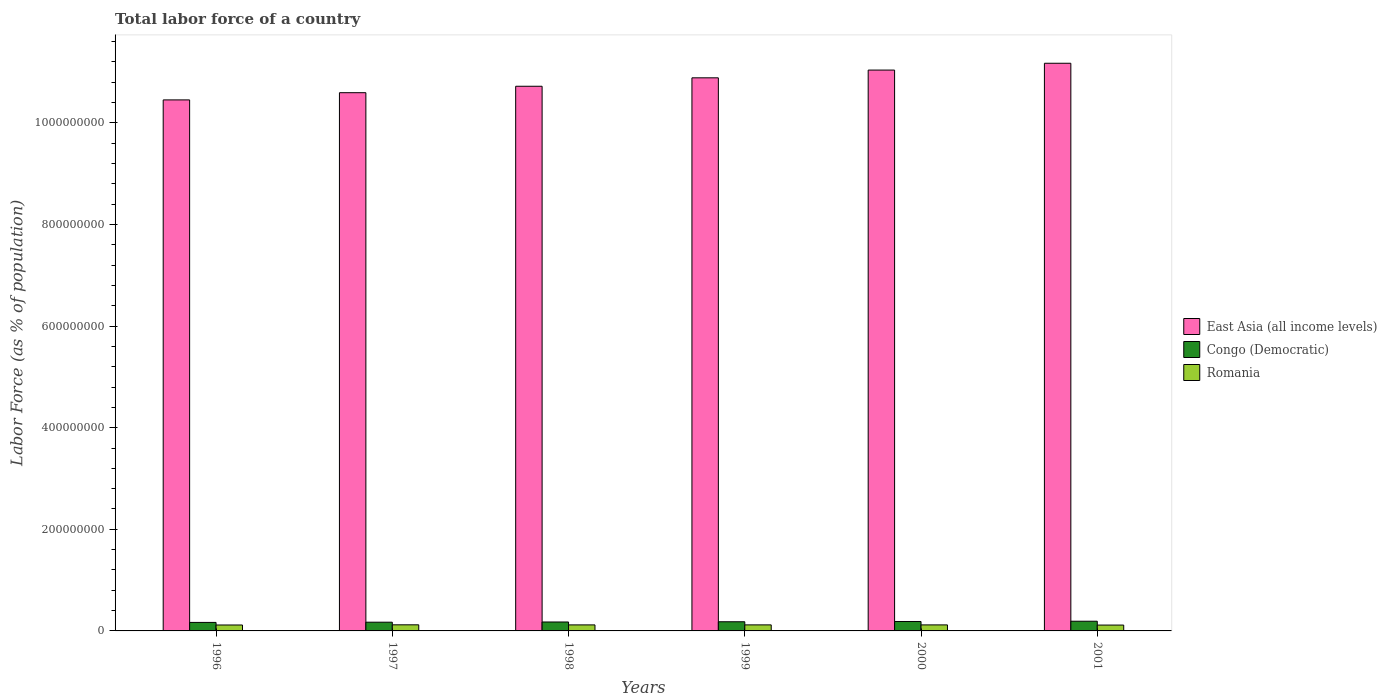How many different coloured bars are there?
Offer a terse response. 3. Are the number of bars on each tick of the X-axis equal?
Your answer should be compact. Yes. How many bars are there on the 5th tick from the left?
Make the answer very short. 3. How many bars are there on the 4th tick from the right?
Your answer should be compact. 3. What is the label of the 1st group of bars from the left?
Your answer should be compact. 1996. What is the percentage of labor force in Romania in 2000?
Keep it short and to the point. 1.19e+07. Across all years, what is the maximum percentage of labor force in Congo (Democratic)?
Provide a succinct answer. 1.91e+07. Across all years, what is the minimum percentage of labor force in Congo (Democratic)?
Keep it short and to the point. 1.67e+07. What is the total percentage of labor force in Romania in the graph?
Your response must be concise. 7.08e+07. What is the difference between the percentage of labor force in Congo (Democratic) in 1996 and that in 2001?
Keep it short and to the point. -2.33e+06. What is the difference between the percentage of labor force in Romania in 1998 and the percentage of labor force in East Asia (all income levels) in 1997?
Offer a very short reply. -1.05e+09. What is the average percentage of labor force in Congo (Democratic) per year?
Keep it short and to the point. 1.79e+07. In the year 2000, what is the difference between the percentage of labor force in East Asia (all income levels) and percentage of labor force in Congo (Democratic)?
Provide a short and direct response. 1.09e+09. What is the ratio of the percentage of labor force in Congo (Democratic) in 1998 to that in 1999?
Give a very brief answer. 0.98. Is the percentage of labor force in East Asia (all income levels) in 1996 less than that in 1999?
Give a very brief answer. Yes. What is the difference between the highest and the second highest percentage of labor force in East Asia (all income levels)?
Keep it short and to the point. 1.34e+07. What is the difference between the highest and the lowest percentage of labor force in Congo (Democratic)?
Your response must be concise. 2.33e+06. In how many years, is the percentage of labor force in East Asia (all income levels) greater than the average percentage of labor force in East Asia (all income levels) taken over all years?
Offer a very short reply. 3. Is the sum of the percentage of labor force in Congo (Democratic) in 1996 and 2001 greater than the maximum percentage of labor force in Romania across all years?
Keep it short and to the point. Yes. What does the 3rd bar from the left in 1999 represents?
Keep it short and to the point. Romania. What does the 2nd bar from the right in 2001 represents?
Your response must be concise. Congo (Democratic). How many bars are there?
Your response must be concise. 18. Are all the bars in the graph horizontal?
Offer a terse response. No. What is the difference between two consecutive major ticks on the Y-axis?
Provide a succinct answer. 2.00e+08. How many legend labels are there?
Provide a short and direct response. 3. How are the legend labels stacked?
Give a very brief answer. Vertical. What is the title of the graph?
Give a very brief answer. Total labor force of a country. Does "Italy" appear as one of the legend labels in the graph?
Provide a succinct answer. No. What is the label or title of the Y-axis?
Ensure brevity in your answer.  Labor Force (as % of population). What is the Labor Force (as % of population) of East Asia (all income levels) in 1996?
Offer a terse response. 1.05e+09. What is the Labor Force (as % of population) in Congo (Democratic) in 1996?
Your response must be concise. 1.67e+07. What is the Labor Force (as % of population) in Romania in 1996?
Offer a very short reply. 1.17e+07. What is the Labor Force (as % of population) in East Asia (all income levels) in 1997?
Offer a very short reply. 1.06e+09. What is the Labor Force (as % of population) in Congo (Democratic) in 1997?
Keep it short and to the point. 1.72e+07. What is the Labor Force (as % of population) of Romania in 1997?
Your answer should be compact. 1.20e+07. What is the Labor Force (as % of population) in East Asia (all income levels) in 1998?
Keep it short and to the point. 1.07e+09. What is the Labor Force (as % of population) of Congo (Democratic) in 1998?
Your response must be concise. 1.76e+07. What is the Labor Force (as % of population) in Romania in 1998?
Your answer should be compact. 1.19e+07. What is the Labor Force (as % of population) in East Asia (all income levels) in 1999?
Give a very brief answer. 1.09e+09. What is the Labor Force (as % of population) of Congo (Democratic) in 1999?
Make the answer very short. 1.80e+07. What is the Labor Force (as % of population) in Romania in 1999?
Your answer should be very brief. 1.19e+07. What is the Labor Force (as % of population) in East Asia (all income levels) in 2000?
Your response must be concise. 1.10e+09. What is the Labor Force (as % of population) of Congo (Democratic) in 2000?
Offer a very short reply. 1.86e+07. What is the Labor Force (as % of population) of Romania in 2000?
Make the answer very short. 1.19e+07. What is the Labor Force (as % of population) of East Asia (all income levels) in 2001?
Your answer should be compact. 1.12e+09. What is the Labor Force (as % of population) of Congo (Democratic) in 2001?
Give a very brief answer. 1.91e+07. What is the Labor Force (as % of population) in Romania in 2001?
Provide a short and direct response. 1.15e+07. Across all years, what is the maximum Labor Force (as % of population) in East Asia (all income levels)?
Offer a very short reply. 1.12e+09. Across all years, what is the maximum Labor Force (as % of population) in Congo (Democratic)?
Provide a short and direct response. 1.91e+07. Across all years, what is the maximum Labor Force (as % of population) of Romania?
Offer a terse response. 1.20e+07. Across all years, what is the minimum Labor Force (as % of population) in East Asia (all income levels)?
Provide a short and direct response. 1.05e+09. Across all years, what is the minimum Labor Force (as % of population) of Congo (Democratic)?
Keep it short and to the point. 1.67e+07. Across all years, what is the minimum Labor Force (as % of population) of Romania?
Ensure brevity in your answer.  1.15e+07. What is the total Labor Force (as % of population) of East Asia (all income levels) in the graph?
Make the answer very short. 6.49e+09. What is the total Labor Force (as % of population) in Congo (Democratic) in the graph?
Your answer should be compact. 1.07e+08. What is the total Labor Force (as % of population) in Romania in the graph?
Give a very brief answer. 7.08e+07. What is the difference between the Labor Force (as % of population) in East Asia (all income levels) in 1996 and that in 1997?
Your response must be concise. -1.42e+07. What is the difference between the Labor Force (as % of population) in Congo (Democratic) in 1996 and that in 1997?
Make the answer very short. -4.31e+05. What is the difference between the Labor Force (as % of population) of Romania in 1996 and that in 1997?
Your response must be concise. -3.55e+05. What is the difference between the Labor Force (as % of population) of East Asia (all income levels) in 1996 and that in 1998?
Keep it short and to the point. -2.69e+07. What is the difference between the Labor Force (as % of population) in Congo (Democratic) in 1996 and that in 1998?
Ensure brevity in your answer.  -8.44e+05. What is the difference between the Labor Force (as % of population) in Romania in 1996 and that in 1998?
Provide a succinct answer. -2.06e+05. What is the difference between the Labor Force (as % of population) of East Asia (all income levels) in 1996 and that in 1999?
Give a very brief answer. -4.35e+07. What is the difference between the Labor Force (as % of population) of Congo (Democratic) in 1996 and that in 1999?
Provide a succinct answer. -1.29e+06. What is the difference between the Labor Force (as % of population) in Romania in 1996 and that in 1999?
Ensure brevity in your answer.  -2.37e+05. What is the difference between the Labor Force (as % of population) in East Asia (all income levels) in 1996 and that in 2000?
Give a very brief answer. -5.87e+07. What is the difference between the Labor Force (as % of population) in Congo (Democratic) in 1996 and that in 2000?
Offer a very short reply. -1.81e+06. What is the difference between the Labor Force (as % of population) of Romania in 1996 and that in 2000?
Your response must be concise. -2.05e+05. What is the difference between the Labor Force (as % of population) in East Asia (all income levels) in 1996 and that in 2001?
Your response must be concise. -7.21e+07. What is the difference between the Labor Force (as % of population) of Congo (Democratic) in 1996 and that in 2001?
Keep it short and to the point. -2.33e+06. What is the difference between the Labor Force (as % of population) in Romania in 1996 and that in 2001?
Your answer should be compact. 1.58e+05. What is the difference between the Labor Force (as % of population) in East Asia (all income levels) in 1997 and that in 1998?
Offer a terse response. -1.27e+07. What is the difference between the Labor Force (as % of population) in Congo (Democratic) in 1997 and that in 1998?
Provide a succinct answer. -4.13e+05. What is the difference between the Labor Force (as % of population) of Romania in 1997 and that in 1998?
Your answer should be compact. 1.49e+05. What is the difference between the Labor Force (as % of population) in East Asia (all income levels) in 1997 and that in 1999?
Offer a terse response. -2.93e+07. What is the difference between the Labor Force (as % of population) in Congo (Democratic) in 1997 and that in 1999?
Your response must be concise. -8.60e+05. What is the difference between the Labor Force (as % of population) in Romania in 1997 and that in 1999?
Make the answer very short. 1.18e+05. What is the difference between the Labor Force (as % of population) of East Asia (all income levels) in 1997 and that in 2000?
Make the answer very short. -4.45e+07. What is the difference between the Labor Force (as % of population) of Congo (Democratic) in 1997 and that in 2000?
Your answer should be very brief. -1.38e+06. What is the difference between the Labor Force (as % of population) of Romania in 1997 and that in 2000?
Provide a succinct answer. 1.50e+05. What is the difference between the Labor Force (as % of population) in East Asia (all income levels) in 1997 and that in 2001?
Give a very brief answer. -5.79e+07. What is the difference between the Labor Force (as % of population) of Congo (Democratic) in 1997 and that in 2001?
Give a very brief answer. -1.89e+06. What is the difference between the Labor Force (as % of population) in Romania in 1997 and that in 2001?
Offer a very short reply. 5.13e+05. What is the difference between the Labor Force (as % of population) of East Asia (all income levels) in 1998 and that in 1999?
Provide a short and direct response. -1.66e+07. What is the difference between the Labor Force (as % of population) of Congo (Democratic) in 1998 and that in 1999?
Keep it short and to the point. -4.47e+05. What is the difference between the Labor Force (as % of population) in Romania in 1998 and that in 1999?
Offer a very short reply. -3.07e+04. What is the difference between the Labor Force (as % of population) in East Asia (all income levels) in 1998 and that in 2000?
Provide a succinct answer. -3.19e+07. What is the difference between the Labor Force (as % of population) of Congo (Democratic) in 1998 and that in 2000?
Offer a very short reply. -9.70e+05. What is the difference between the Labor Force (as % of population) in Romania in 1998 and that in 2000?
Your answer should be compact. 1094. What is the difference between the Labor Force (as % of population) of East Asia (all income levels) in 1998 and that in 2001?
Offer a very short reply. -4.53e+07. What is the difference between the Labor Force (as % of population) in Congo (Democratic) in 1998 and that in 2001?
Ensure brevity in your answer.  -1.48e+06. What is the difference between the Labor Force (as % of population) in Romania in 1998 and that in 2001?
Keep it short and to the point. 3.64e+05. What is the difference between the Labor Force (as % of population) of East Asia (all income levels) in 1999 and that in 2000?
Provide a short and direct response. -1.53e+07. What is the difference between the Labor Force (as % of population) in Congo (Democratic) in 1999 and that in 2000?
Your answer should be very brief. -5.23e+05. What is the difference between the Labor Force (as % of population) of Romania in 1999 and that in 2000?
Give a very brief answer. 3.18e+04. What is the difference between the Labor Force (as % of population) of East Asia (all income levels) in 1999 and that in 2001?
Offer a terse response. -2.87e+07. What is the difference between the Labor Force (as % of population) of Congo (Democratic) in 1999 and that in 2001?
Provide a short and direct response. -1.03e+06. What is the difference between the Labor Force (as % of population) of Romania in 1999 and that in 2001?
Offer a very short reply. 3.95e+05. What is the difference between the Labor Force (as % of population) in East Asia (all income levels) in 2000 and that in 2001?
Your answer should be compact. -1.34e+07. What is the difference between the Labor Force (as % of population) in Congo (Democratic) in 2000 and that in 2001?
Provide a succinct answer. -5.12e+05. What is the difference between the Labor Force (as % of population) in Romania in 2000 and that in 2001?
Provide a short and direct response. 3.63e+05. What is the difference between the Labor Force (as % of population) of East Asia (all income levels) in 1996 and the Labor Force (as % of population) of Congo (Democratic) in 1997?
Give a very brief answer. 1.03e+09. What is the difference between the Labor Force (as % of population) of East Asia (all income levels) in 1996 and the Labor Force (as % of population) of Romania in 1997?
Keep it short and to the point. 1.03e+09. What is the difference between the Labor Force (as % of population) in Congo (Democratic) in 1996 and the Labor Force (as % of population) in Romania in 1997?
Make the answer very short. 4.72e+06. What is the difference between the Labor Force (as % of population) of East Asia (all income levels) in 1996 and the Labor Force (as % of population) of Congo (Democratic) in 1998?
Give a very brief answer. 1.03e+09. What is the difference between the Labor Force (as % of population) in East Asia (all income levels) in 1996 and the Labor Force (as % of population) in Romania in 1998?
Offer a terse response. 1.03e+09. What is the difference between the Labor Force (as % of population) of Congo (Democratic) in 1996 and the Labor Force (as % of population) of Romania in 1998?
Your response must be concise. 4.87e+06. What is the difference between the Labor Force (as % of population) in East Asia (all income levels) in 1996 and the Labor Force (as % of population) in Congo (Democratic) in 1999?
Offer a very short reply. 1.03e+09. What is the difference between the Labor Force (as % of population) in East Asia (all income levels) in 1996 and the Labor Force (as % of population) in Romania in 1999?
Provide a short and direct response. 1.03e+09. What is the difference between the Labor Force (as % of population) of Congo (Democratic) in 1996 and the Labor Force (as % of population) of Romania in 1999?
Ensure brevity in your answer.  4.84e+06. What is the difference between the Labor Force (as % of population) of East Asia (all income levels) in 1996 and the Labor Force (as % of population) of Congo (Democratic) in 2000?
Your response must be concise. 1.03e+09. What is the difference between the Labor Force (as % of population) of East Asia (all income levels) in 1996 and the Labor Force (as % of population) of Romania in 2000?
Your answer should be compact. 1.03e+09. What is the difference between the Labor Force (as % of population) in Congo (Democratic) in 1996 and the Labor Force (as % of population) in Romania in 2000?
Make the answer very short. 4.87e+06. What is the difference between the Labor Force (as % of population) in East Asia (all income levels) in 1996 and the Labor Force (as % of population) in Congo (Democratic) in 2001?
Keep it short and to the point. 1.03e+09. What is the difference between the Labor Force (as % of population) in East Asia (all income levels) in 1996 and the Labor Force (as % of population) in Romania in 2001?
Offer a very short reply. 1.03e+09. What is the difference between the Labor Force (as % of population) in Congo (Democratic) in 1996 and the Labor Force (as % of population) in Romania in 2001?
Give a very brief answer. 5.24e+06. What is the difference between the Labor Force (as % of population) in East Asia (all income levels) in 1997 and the Labor Force (as % of population) in Congo (Democratic) in 1998?
Ensure brevity in your answer.  1.04e+09. What is the difference between the Labor Force (as % of population) of East Asia (all income levels) in 1997 and the Labor Force (as % of population) of Romania in 1998?
Provide a short and direct response. 1.05e+09. What is the difference between the Labor Force (as % of population) in Congo (Democratic) in 1997 and the Labor Force (as % of population) in Romania in 1998?
Your answer should be compact. 5.30e+06. What is the difference between the Labor Force (as % of population) in East Asia (all income levels) in 1997 and the Labor Force (as % of population) in Congo (Democratic) in 1999?
Offer a very short reply. 1.04e+09. What is the difference between the Labor Force (as % of population) in East Asia (all income levels) in 1997 and the Labor Force (as % of population) in Romania in 1999?
Provide a succinct answer. 1.05e+09. What is the difference between the Labor Force (as % of population) of Congo (Democratic) in 1997 and the Labor Force (as % of population) of Romania in 1999?
Your answer should be very brief. 5.27e+06. What is the difference between the Labor Force (as % of population) in East Asia (all income levels) in 1997 and the Labor Force (as % of population) in Congo (Democratic) in 2000?
Keep it short and to the point. 1.04e+09. What is the difference between the Labor Force (as % of population) in East Asia (all income levels) in 1997 and the Labor Force (as % of population) in Romania in 2000?
Keep it short and to the point. 1.05e+09. What is the difference between the Labor Force (as % of population) in Congo (Democratic) in 1997 and the Labor Force (as % of population) in Romania in 2000?
Ensure brevity in your answer.  5.30e+06. What is the difference between the Labor Force (as % of population) of East Asia (all income levels) in 1997 and the Labor Force (as % of population) of Congo (Democratic) in 2001?
Offer a very short reply. 1.04e+09. What is the difference between the Labor Force (as % of population) of East Asia (all income levels) in 1997 and the Labor Force (as % of population) of Romania in 2001?
Offer a very short reply. 1.05e+09. What is the difference between the Labor Force (as % of population) of Congo (Democratic) in 1997 and the Labor Force (as % of population) of Romania in 2001?
Your answer should be very brief. 5.67e+06. What is the difference between the Labor Force (as % of population) in East Asia (all income levels) in 1998 and the Labor Force (as % of population) in Congo (Democratic) in 1999?
Your answer should be compact. 1.05e+09. What is the difference between the Labor Force (as % of population) in East Asia (all income levels) in 1998 and the Labor Force (as % of population) in Romania in 1999?
Make the answer very short. 1.06e+09. What is the difference between the Labor Force (as % of population) in Congo (Democratic) in 1998 and the Labor Force (as % of population) in Romania in 1999?
Your answer should be compact. 5.69e+06. What is the difference between the Labor Force (as % of population) in East Asia (all income levels) in 1998 and the Labor Force (as % of population) in Congo (Democratic) in 2000?
Offer a very short reply. 1.05e+09. What is the difference between the Labor Force (as % of population) in East Asia (all income levels) in 1998 and the Labor Force (as % of population) in Romania in 2000?
Your response must be concise. 1.06e+09. What is the difference between the Labor Force (as % of population) of Congo (Democratic) in 1998 and the Labor Force (as % of population) of Romania in 2000?
Ensure brevity in your answer.  5.72e+06. What is the difference between the Labor Force (as % of population) in East Asia (all income levels) in 1998 and the Labor Force (as % of population) in Congo (Democratic) in 2001?
Offer a very short reply. 1.05e+09. What is the difference between the Labor Force (as % of population) of East Asia (all income levels) in 1998 and the Labor Force (as % of population) of Romania in 2001?
Your response must be concise. 1.06e+09. What is the difference between the Labor Force (as % of population) in Congo (Democratic) in 1998 and the Labor Force (as % of population) in Romania in 2001?
Provide a succinct answer. 6.08e+06. What is the difference between the Labor Force (as % of population) in East Asia (all income levels) in 1999 and the Labor Force (as % of population) in Congo (Democratic) in 2000?
Give a very brief answer. 1.07e+09. What is the difference between the Labor Force (as % of population) of East Asia (all income levels) in 1999 and the Labor Force (as % of population) of Romania in 2000?
Your answer should be compact. 1.08e+09. What is the difference between the Labor Force (as % of population) in Congo (Democratic) in 1999 and the Labor Force (as % of population) in Romania in 2000?
Your answer should be compact. 6.16e+06. What is the difference between the Labor Force (as % of population) of East Asia (all income levels) in 1999 and the Labor Force (as % of population) of Congo (Democratic) in 2001?
Offer a very short reply. 1.07e+09. What is the difference between the Labor Force (as % of population) in East Asia (all income levels) in 1999 and the Labor Force (as % of population) in Romania in 2001?
Ensure brevity in your answer.  1.08e+09. What is the difference between the Labor Force (as % of population) in Congo (Democratic) in 1999 and the Labor Force (as % of population) in Romania in 2001?
Offer a terse response. 6.53e+06. What is the difference between the Labor Force (as % of population) in East Asia (all income levels) in 2000 and the Labor Force (as % of population) in Congo (Democratic) in 2001?
Ensure brevity in your answer.  1.08e+09. What is the difference between the Labor Force (as % of population) in East Asia (all income levels) in 2000 and the Labor Force (as % of population) in Romania in 2001?
Your answer should be very brief. 1.09e+09. What is the difference between the Labor Force (as % of population) in Congo (Democratic) in 2000 and the Labor Force (as % of population) in Romania in 2001?
Offer a very short reply. 7.05e+06. What is the average Labor Force (as % of population) in East Asia (all income levels) per year?
Provide a succinct answer. 1.08e+09. What is the average Labor Force (as % of population) in Congo (Democratic) per year?
Your answer should be compact. 1.79e+07. What is the average Labor Force (as % of population) in Romania per year?
Provide a succinct answer. 1.18e+07. In the year 1996, what is the difference between the Labor Force (as % of population) in East Asia (all income levels) and Labor Force (as % of population) in Congo (Democratic)?
Provide a succinct answer. 1.03e+09. In the year 1996, what is the difference between the Labor Force (as % of population) of East Asia (all income levels) and Labor Force (as % of population) of Romania?
Offer a terse response. 1.03e+09. In the year 1996, what is the difference between the Labor Force (as % of population) of Congo (Democratic) and Labor Force (as % of population) of Romania?
Provide a short and direct response. 5.08e+06. In the year 1997, what is the difference between the Labor Force (as % of population) in East Asia (all income levels) and Labor Force (as % of population) in Congo (Democratic)?
Provide a short and direct response. 1.04e+09. In the year 1997, what is the difference between the Labor Force (as % of population) of East Asia (all income levels) and Labor Force (as % of population) of Romania?
Your response must be concise. 1.05e+09. In the year 1997, what is the difference between the Labor Force (as % of population) in Congo (Democratic) and Labor Force (as % of population) in Romania?
Make the answer very short. 5.15e+06. In the year 1998, what is the difference between the Labor Force (as % of population) in East Asia (all income levels) and Labor Force (as % of population) in Congo (Democratic)?
Your answer should be very brief. 1.05e+09. In the year 1998, what is the difference between the Labor Force (as % of population) in East Asia (all income levels) and Labor Force (as % of population) in Romania?
Ensure brevity in your answer.  1.06e+09. In the year 1998, what is the difference between the Labor Force (as % of population) of Congo (Democratic) and Labor Force (as % of population) of Romania?
Provide a succinct answer. 5.72e+06. In the year 1999, what is the difference between the Labor Force (as % of population) of East Asia (all income levels) and Labor Force (as % of population) of Congo (Democratic)?
Your answer should be compact. 1.07e+09. In the year 1999, what is the difference between the Labor Force (as % of population) of East Asia (all income levels) and Labor Force (as % of population) of Romania?
Offer a terse response. 1.08e+09. In the year 1999, what is the difference between the Labor Force (as % of population) in Congo (Democratic) and Labor Force (as % of population) in Romania?
Provide a succinct answer. 6.13e+06. In the year 2000, what is the difference between the Labor Force (as % of population) in East Asia (all income levels) and Labor Force (as % of population) in Congo (Democratic)?
Ensure brevity in your answer.  1.09e+09. In the year 2000, what is the difference between the Labor Force (as % of population) of East Asia (all income levels) and Labor Force (as % of population) of Romania?
Give a very brief answer. 1.09e+09. In the year 2000, what is the difference between the Labor Force (as % of population) in Congo (Democratic) and Labor Force (as % of population) in Romania?
Keep it short and to the point. 6.69e+06. In the year 2001, what is the difference between the Labor Force (as % of population) of East Asia (all income levels) and Labor Force (as % of population) of Congo (Democratic)?
Your response must be concise. 1.10e+09. In the year 2001, what is the difference between the Labor Force (as % of population) of East Asia (all income levels) and Labor Force (as % of population) of Romania?
Your response must be concise. 1.11e+09. In the year 2001, what is the difference between the Labor Force (as % of population) in Congo (Democratic) and Labor Force (as % of population) in Romania?
Keep it short and to the point. 7.56e+06. What is the ratio of the Labor Force (as % of population) in East Asia (all income levels) in 1996 to that in 1997?
Ensure brevity in your answer.  0.99. What is the ratio of the Labor Force (as % of population) in Congo (Democratic) in 1996 to that in 1997?
Offer a terse response. 0.97. What is the ratio of the Labor Force (as % of population) of Romania in 1996 to that in 1997?
Provide a short and direct response. 0.97. What is the ratio of the Labor Force (as % of population) in East Asia (all income levels) in 1996 to that in 1998?
Your answer should be compact. 0.97. What is the ratio of the Labor Force (as % of population) in Romania in 1996 to that in 1998?
Give a very brief answer. 0.98. What is the ratio of the Labor Force (as % of population) in East Asia (all income levels) in 1996 to that in 1999?
Provide a succinct answer. 0.96. What is the ratio of the Labor Force (as % of population) of Congo (Democratic) in 1996 to that in 1999?
Your answer should be very brief. 0.93. What is the ratio of the Labor Force (as % of population) of Romania in 1996 to that in 1999?
Ensure brevity in your answer.  0.98. What is the ratio of the Labor Force (as % of population) of East Asia (all income levels) in 1996 to that in 2000?
Make the answer very short. 0.95. What is the ratio of the Labor Force (as % of population) of Congo (Democratic) in 1996 to that in 2000?
Give a very brief answer. 0.9. What is the ratio of the Labor Force (as % of population) of Romania in 1996 to that in 2000?
Make the answer very short. 0.98. What is the ratio of the Labor Force (as % of population) of East Asia (all income levels) in 1996 to that in 2001?
Provide a short and direct response. 0.94. What is the ratio of the Labor Force (as % of population) in Congo (Democratic) in 1996 to that in 2001?
Make the answer very short. 0.88. What is the ratio of the Labor Force (as % of population) of Romania in 1996 to that in 2001?
Offer a very short reply. 1.01. What is the ratio of the Labor Force (as % of population) in Congo (Democratic) in 1997 to that in 1998?
Your answer should be very brief. 0.98. What is the ratio of the Labor Force (as % of population) of Romania in 1997 to that in 1998?
Give a very brief answer. 1.01. What is the ratio of the Labor Force (as % of population) of East Asia (all income levels) in 1997 to that in 1999?
Make the answer very short. 0.97. What is the ratio of the Labor Force (as % of population) in Congo (Democratic) in 1997 to that in 1999?
Keep it short and to the point. 0.95. What is the ratio of the Labor Force (as % of population) in Romania in 1997 to that in 1999?
Keep it short and to the point. 1.01. What is the ratio of the Labor Force (as % of population) in East Asia (all income levels) in 1997 to that in 2000?
Provide a short and direct response. 0.96. What is the ratio of the Labor Force (as % of population) of Congo (Democratic) in 1997 to that in 2000?
Provide a succinct answer. 0.93. What is the ratio of the Labor Force (as % of population) in Romania in 1997 to that in 2000?
Make the answer very short. 1.01. What is the ratio of the Labor Force (as % of population) of East Asia (all income levels) in 1997 to that in 2001?
Ensure brevity in your answer.  0.95. What is the ratio of the Labor Force (as % of population) of Congo (Democratic) in 1997 to that in 2001?
Provide a short and direct response. 0.9. What is the ratio of the Labor Force (as % of population) of Romania in 1997 to that in 2001?
Provide a succinct answer. 1.04. What is the ratio of the Labor Force (as % of population) of Congo (Democratic) in 1998 to that in 1999?
Offer a very short reply. 0.98. What is the ratio of the Labor Force (as % of population) of Romania in 1998 to that in 1999?
Your answer should be compact. 1. What is the ratio of the Labor Force (as % of population) of East Asia (all income levels) in 1998 to that in 2000?
Keep it short and to the point. 0.97. What is the ratio of the Labor Force (as % of population) in Congo (Democratic) in 1998 to that in 2000?
Your answer should be very brief. 0.95. What is the ratio of the Labor Force (as % of population) in Romania in 1998 to that in 2000?
Keep it short and to the point. 1. What is the ratio of the Labor Force (as % of population) of East Asia (all income levels) in 1998 to that in 2001?
Offer a very short reply. 0.96. What is the ratio of the Labor Force (as % of population) of Congo (Democratic) in 1998 to that in 2001?
Your answer should be compact. 0.92. What is the ratio of the Labor Force (as % of population) in Romania in 1998 to that in 2001?
Offer a very short reply. 1.03. What is the ratio of the Labor Force (as % of population) in East Asia (all income levels) in 1999 to that in 2000?
Your answer should be compact. 0.99. What is the ratio of the Labor Force (as % of population) of Congo (Democratic) in 1999 to that in 2000?
Offer a terse response. 0.97. What is the ratio of the Labor Force (as % of population) in Romania in 1999 to that in 2000?
Your answer should be compact. 1. What is the ratio of the Labor Force (as % of population) in East Asia (all income levels) in 1999 to that in 2001?
Offer a terse response. 0.97. What is the ratio of the Labor Force (as % of population) in Congo (Democratic) in 1999 to that in 2001?
Give a very brief answer. 0.95. What is the ratio of the Labor Force (as % of population) in Romania in 1999 to that in 2001?
Offer a very short reply. 1.03. What is the ratio of the Labor Force (as % of population) in Congo (Democratic) in 2000 to that in 2001?
Give a very brief answer. 0.97. What is the ratio of the Labor Force (as % of population) in Romania in 2000 to that in 2001?
Your response must be concise. 1.03. What is the difference between the highest and the second highest Labor Force (as % of population) of East Asia (all income levels)?
Provide a succinct answer. 1.34e+07. What is the difference between the highest and the second highest Labor Force (as % of population) in Congo (Democratic)?
Give a very brief answer. 5.12e+05. What is the difference between the highest and the second highest Labor Force (as % of population) in Romania?
Offer a terse response. 1.18e+05. What is the difference between the highest and the lowest Labor Force (as % of population) of East Asia (all income levels)?
Offer a very short reply. 7.21e+07. What is the difference between the highest and the lowest Labor Force (as % of population) in Congo (Democratic)?
Provide a short and direct response. 2.33e+06. What is the difference between the highest and the lowest Labor Force (as % of population) in Romania?
Provide a short and direct response. 5.13e+05. 